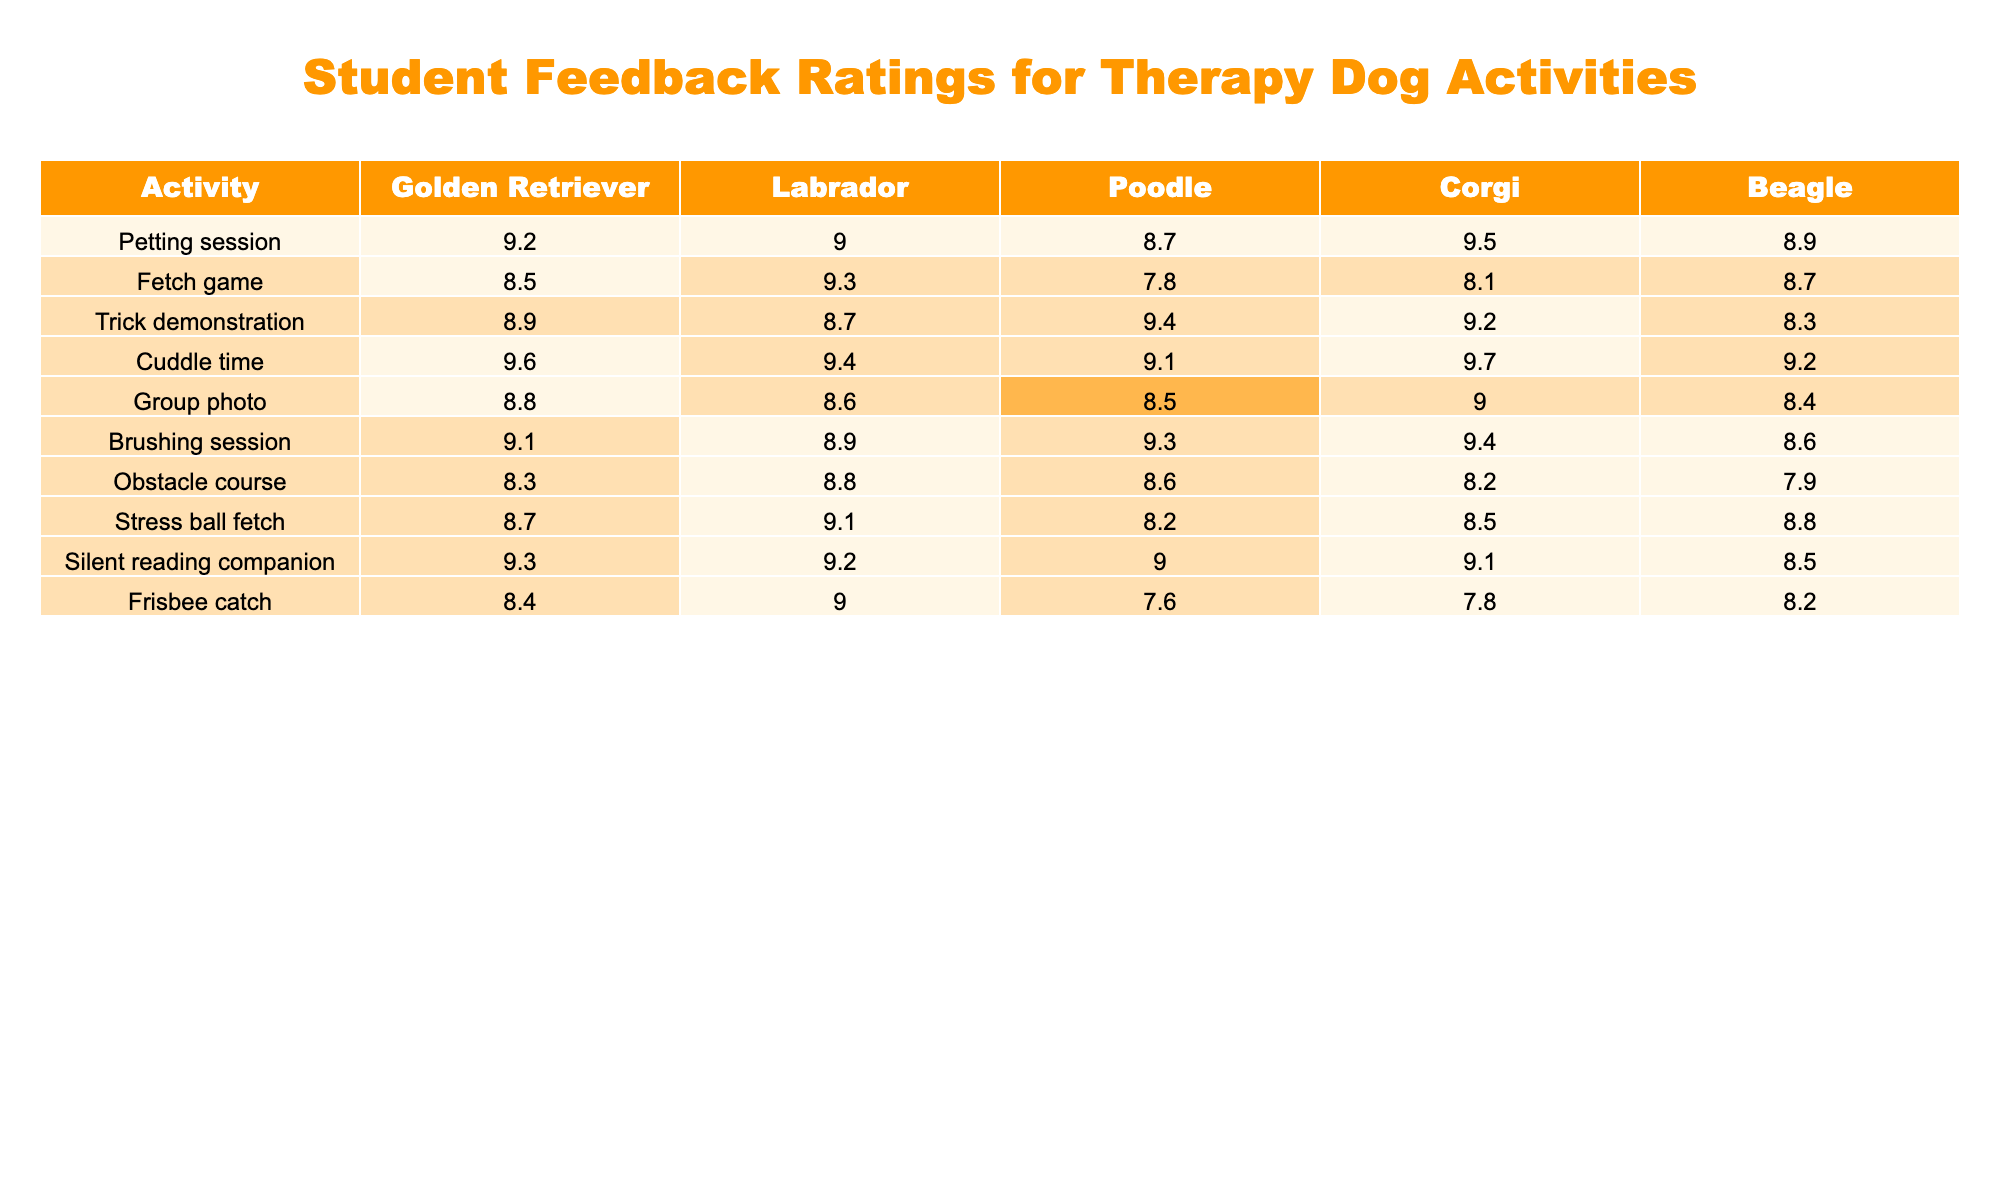What is the highest rating for the Corgi's cuddle time activity? The cuddle time rating for Corgis is 9.7, which can be found directly in the table as the highest value under the Corgi column for that activity.
Answer: 9.7 Which dog breed received the lowest rating for the fetch game? The lowest rating for the fetch game among the breeds is 7.8, which is listed under the Poodle column for that activity.
Answer: Poodle What is the average rating for the Golden Retriever across all activities? To find the average, sum the Golden Retriever ratings (9.2 + 8.5 + 8.9 + 9.6 + 8.8 + 9.1 + 8.3 + 8.7 + 9.3 + 8.4), which equals 88.8, and divide by the number of activities (10), which results in an average of 8.88.
Answer: 8.88 Did the Beagle ever receive a rating above 9? The ratings for the Beagle in all activities are 8.9, 8.7, 8.3, 9.2, 8.4, 8.6, 7.9, 8.8, and 8.2. None of these values exceed 9, so the answer is no.
Answer: No Which activity has the highest overall rating among all breeds? To determine this, we look for the highest rating across all activities. The highest rating is 9.7 for cuddle time with the Corgi, making it the top activity overall.
Answer: Cuddle time What is the difference between the average rating of the Labrador and the average rating of the Poodle? First, calculate the average for each breed: Labrador's ratings sum to 88.4 leading to an average of 8.84, and Poodle's sum is 87.3 with an average of 8.73. The difference (8.84 - 8.73) equals 0.11.
Answer: 0.11 For the obstacle course, which dog breed had the highest rating? Looking at the obstacle course row, the ratings are 8.3, 8.8, 8.6, 8.2, and 7.9 for the Golden Retriever, Labrador, Poodle, Corgi, and Beagle respectively. The highest value is 8.8 for the Labrador.
Answer: Labrador Which activity received consistently high ratings (9 or above) across more than one dog breed? By examining the table, cuddle time has ratings of 9.6, 9.4, 9.1, 9.7, and 9.2, which shows that multiple breeds rated this activity above 9.
Answer: Cuddle time Is the average rating for the brushing session higher than 9 for any breed? The ratings for brushing sessions are 9.1, 8.9, 9.3, 9.4, and 8.6. The only breed with an average above 9 in this activity is the Corgi with a rating of 9.4.
Answer: Yes, for Corgi 